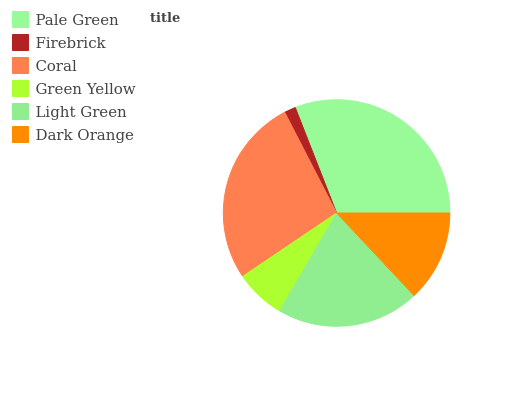Is Firebrick the minimum?
Answer yes or no. Yes. Is Pale Green the maximum?
Answer yes or no. Yes. Is Coral the minimum?
Answer yes or no. No. Is Coral the maximum?
Answer yes or no. No. Is Coral greater than Firebrick?
Answer yes or no. Yes. Is Firebrick less than Coral?
Answer yes or no. Yes. Is Firebrick greater than Coral?
Answer yes or no. No. Is Coral less than Firebrick?
Answer yes or no. No. Is Light Green the high median?
Answer yes or no. Yes. Is Dark Orange the low median?
Answer yes or no. Yes. Is Green Yellow the high median?
Answer yes or no. No. Is Light Green the low median?
Answer yes or no. No. 